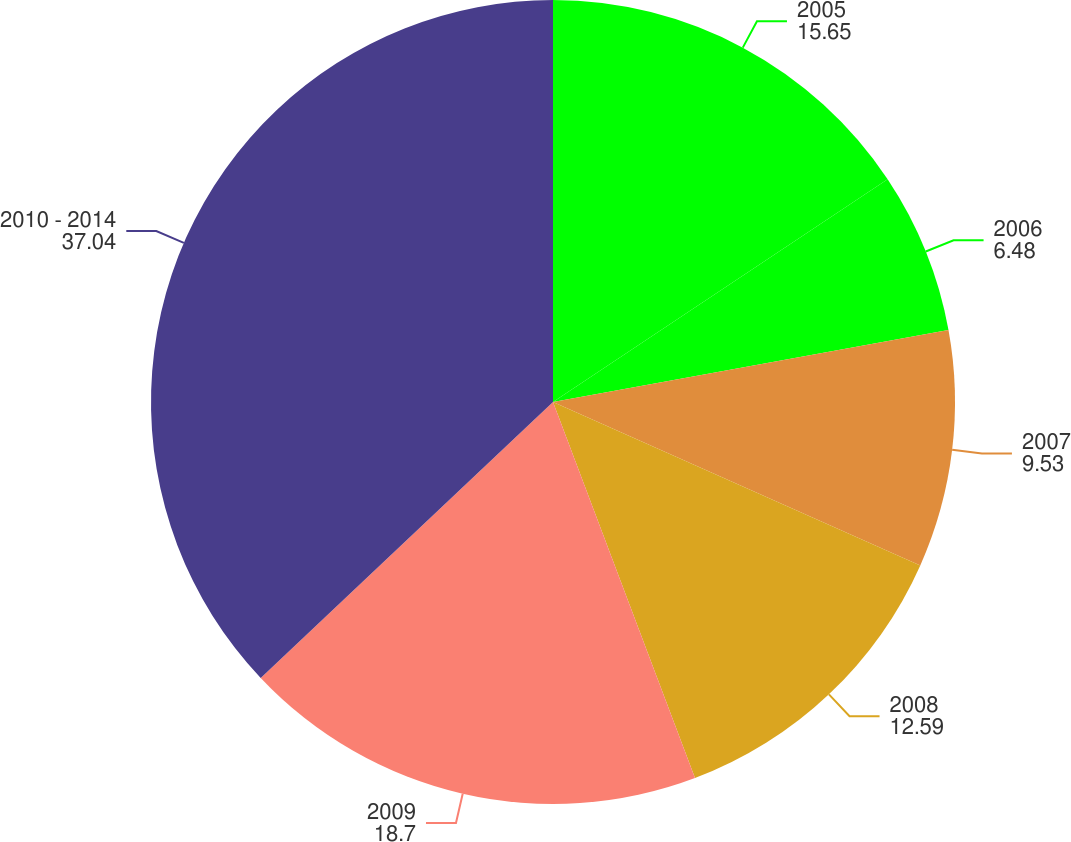Convert chart to OTSL. <chart><loc_0><loc_0><loc_500><loc_500><pie_chart><fcel>2005<fcel>2006<fcel>2007<fcel>2008<fcel>2009<fcel>2010 - 2014<nl><fcel>15.65%<fcel>6.48%<fcel>9.53%<fcel>12.59%<fcel>18.7%<fcel>37.04%<nl></chart> 